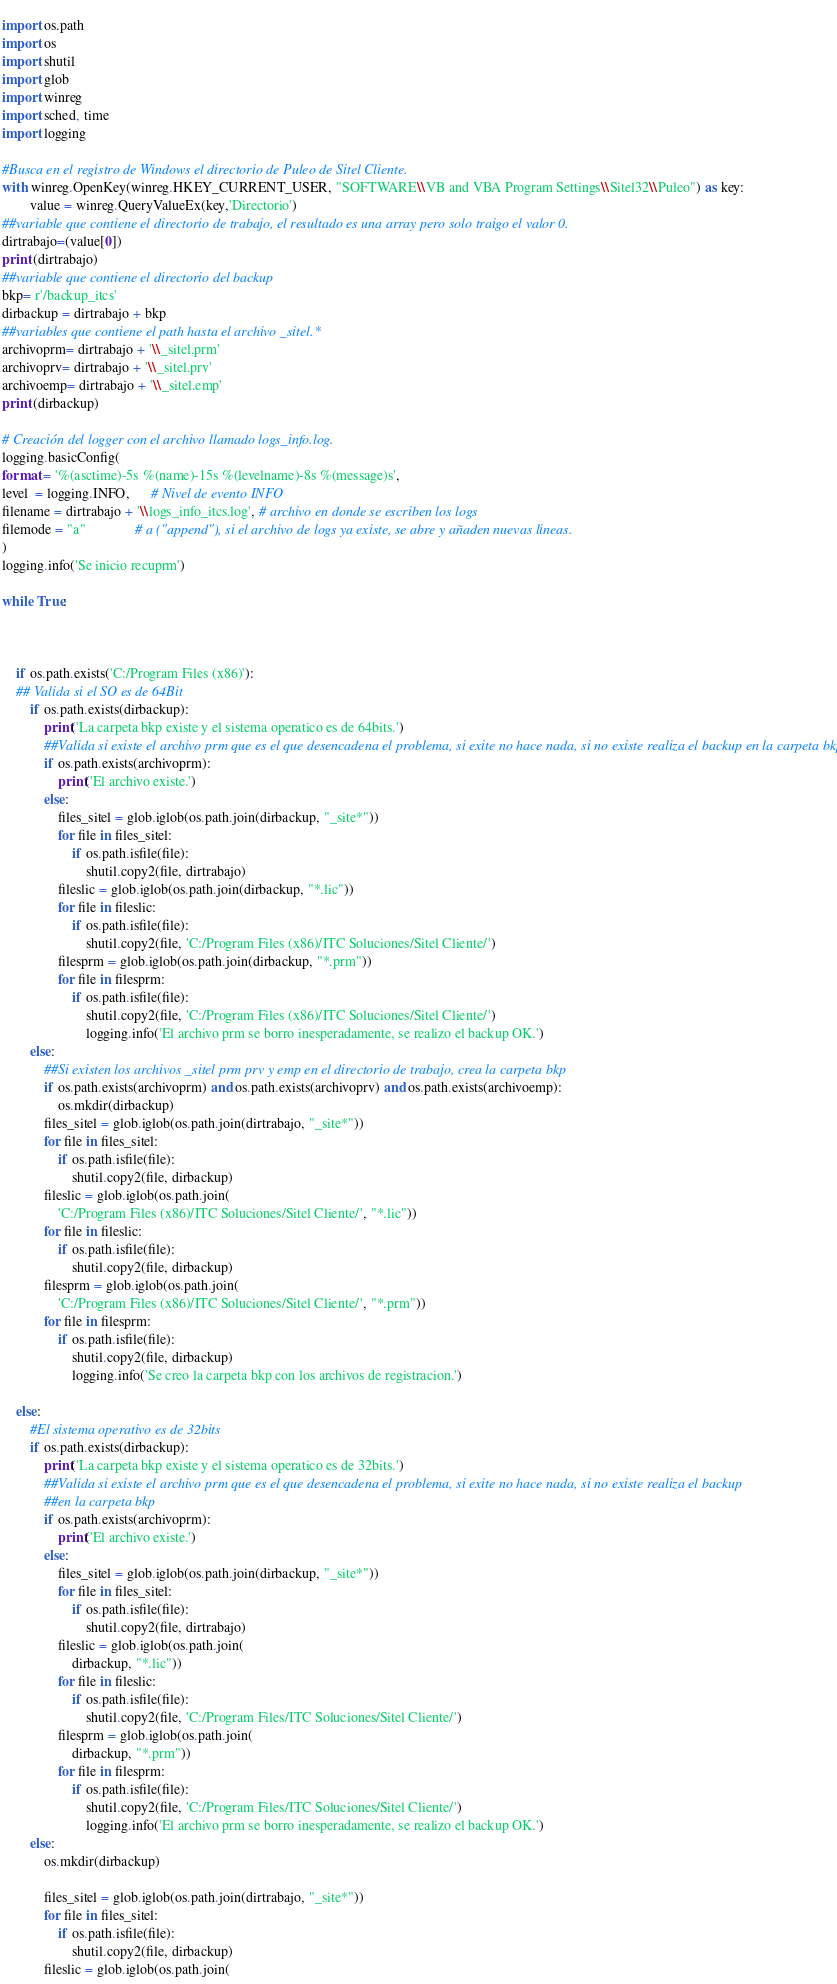Convert code to text. <code><loc_0><loc_0><loc_500><loc_500><_Python_>  
import os.path
import os
import shutil
import glob
import winreg
import sched, time
import logging

#Busca en el registro de Windows el directorio de Puleo de Sitel Cliente.
with winreg.OpenKey(winreg.HKEY_CURRENT_USER, "SOFTWARE\\VB and VBA Program Settings\\Sitel32\\Puleo") as key:
        value = winreg.QueryValueEx(key,'Directorio')
##variable que contiene el directorio de trabajo, el resultado es una array pero solo traigo el valor 0.
dirtrabajo=(value[0])
print (dirtrabajo)
##variable que contiene el directorio del backup
bkp= r'/backup_itcs'
dirbackup = dirtrabajo + bkp
##variables que contiene el path hasta el archivo _sitel.*
archivoprm= dirtrabajo + '\\_sitel.prm'
archivoprv= dirtrabajo + '\\_sitel.prv'
archivoemp= dirtrabajo + '\\_sitel.emp'
print (dirbackup)

# Creación del logger con el archivo llamado logs_info.log.
logging.basicConfig(
format = '%(asctime)-5s %(name)-15s %(levelname)-8s %(message)s',
level  = logging.INFO,      # Nivel de evento INFO
filename = dirtrabajo + '\\logs_info_itcs.log', # archivo en donde se escriben los logs
filemode = "a"              # a ("append"), si el archivo de logs ya existe, se abre y añaden nuevas lineas.
)
logging.info('Se inicio recuprm')

while True:



    if os.path.exists('C:/Program Files (x86)'):
    ## Valida si el SO es de 64Bit  
        if os.path.exists(dirbackup):
            print('La carpeta bkp existe y el sistema operatico es de 64bits.')
            ##Valida si existe el archivo prm que es el que desencadena el problema, si exite no hace nada, si no existe realiza el backup en la carpeta bkp
            if os.path.exists(archivoprm):
                print('El archivo existe.')
            else:
                files_sitel = glob.iglob(os.path.join(dirbackup, "_site*"))
                for file in files_sitel:
                    if os.path.isfile(file):
                        shutil.copy2(file, dirtrabajo)
                fileslic = glob.iglob(os.path.join(dirbackup, "*.lic"))
                for file in fileslic:
                    if os.path.isfile(file):
                        shutil.copy2(file, 'C:/Program Files (x86)/ITC Soluciones/Sitel Cliente/')
                filesprm = glob.iglob(os.path.join(dirbackup, "*.prm"))
                for file in filesprm:
                    if os.path.isfile(file):
                        shutil.copy2(file, 'C:/Program Files (x86)/ITC Soluciones/Sitel Cliente/')
                        logging.info('El archivo prm se borro inesperadamente, se realizo el backup OK.')
        else:
            ##Si existen los archivos _sitel prm prv y emp en el directorio de trabajo, crea la carpeta bkp
            if os.path.exists(archivoprm) and os.path.exists(archivoprv) and os.path.exists(archivoemp):
                os.mkdir(dirbackup)
            files_sitel = glob.iglob(os.path.join(dirtrabajo, "_site*"))
            for file in files_sitel:
                if os.path.isfile(file):
                    shutil.copy2(file, dirbackup)
            fileslic = glob.iglob(os.path.join(
                'C:/Program Files (x86)/ITC Soluciones/Sitel Cliente/', "*.lic"))
            for file in fileslic:
                if os.path.isfile(file):
                    shutil.copy2(file, dirbackup)
            filesprm = glob.iglob(os.path.join(
                'C:/Program Files (x86)/ITC Soluciones/Sitel Cliente/', "*.prm"))
            for file in filesprm:
                if os.path.isfile(file):
                    shutil.copy2(file, dirbackup)
                    logging.info('Se creo la carpeta bkp con los archivos de registracion.')

    else:
        #El sistema operativo es de 32bits 
        if os.path.exists(dirbackup):
            print('La carpeta bkp existe y el sistema operatico es de 32bits.')
            ##Valida si existe el archivo prm que es el que desencadena el problema, si exite no hace nada, si no existe realiza el backup
            ##en la carpeta bkp
            if os.path.exists(archivoprm):
                print('El archivo existe.')
            else:
                files_sitel = glob.iglob(os.path.join(dirbackup, "_site*"))
                for file in files_sitel:
                    if os.path.isfile(file):
                        shutil.copy2(file, dirtrabajo)
                fileslic = glob.iglob(os.path.join(
                    dirbackup, "*.lic"))
                for file in fileslic:
                    if os.path.isfile(file):
                        shutil.copy2(file, 'C:/Program Files/ITC Soluciones/Sitel Cliente/')
                filesprm = glob.iglob(os.path.join(
                    dirbackup, "*.prm"))
                for file in filesprm:
                    if os.path.isfile(file):
                        shutil.copy2(file, 'C:/Program Files/ITC Soluciones/Sitel Cliente/')
                        logging.info('El archivo prm se borro inesperadamente, se realizo el backup OK.')
        else:
            os.mkdir(dirbackup)

            files_sitel = glob.iglob(os.path.join(dirtrabajo, "_site*"))
            for file in files_sitel:
                if os.path.isfile(file):
                    shutil.copy2(file, dirbackup)
            fileslic = glob.iglob(os.path.join(</code> 